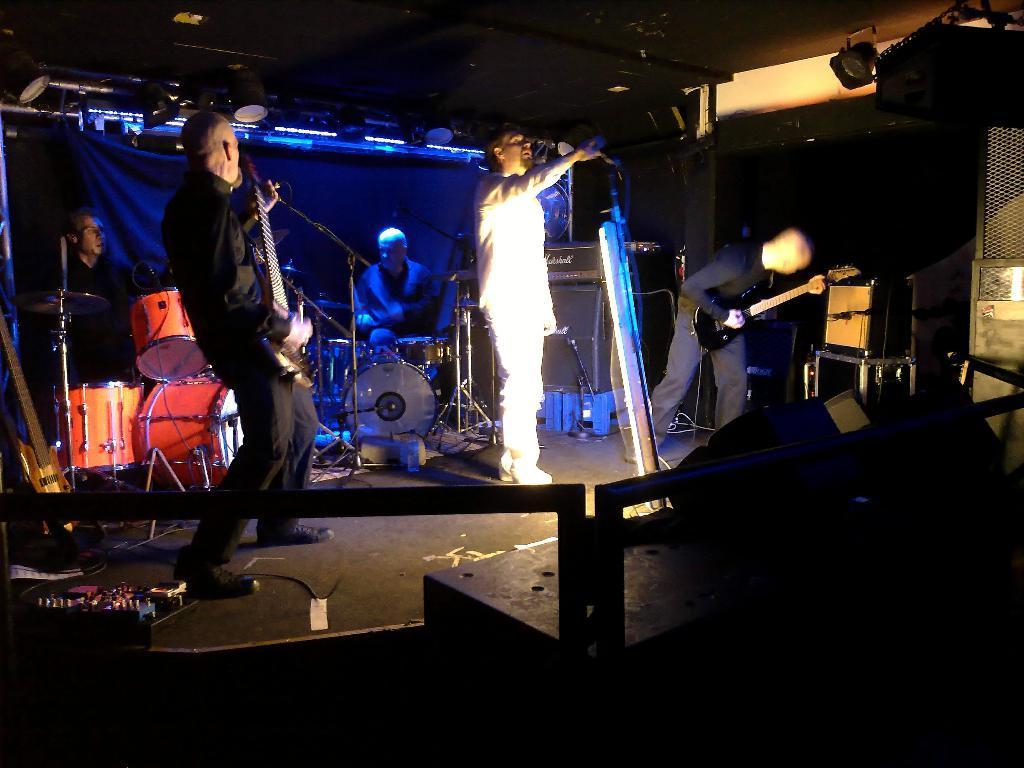In one or two sentences, can you explain what this image depicts? The image looks like it is taken in a studio. In the foreground there is railing. In the center of the picture we can see a band performing. On the right it is a speaker. In the center of the picture there is a person standing and singing. On the left there is a person playing guitar and another person playing drums. In the center of the picture, in the background there is a person playing drums. In the background, at the top there are lights. Towards right there is a person playing guitar. In this picture there are speakers, cables, mics, music control systems and other objects. At the top it is dark. 